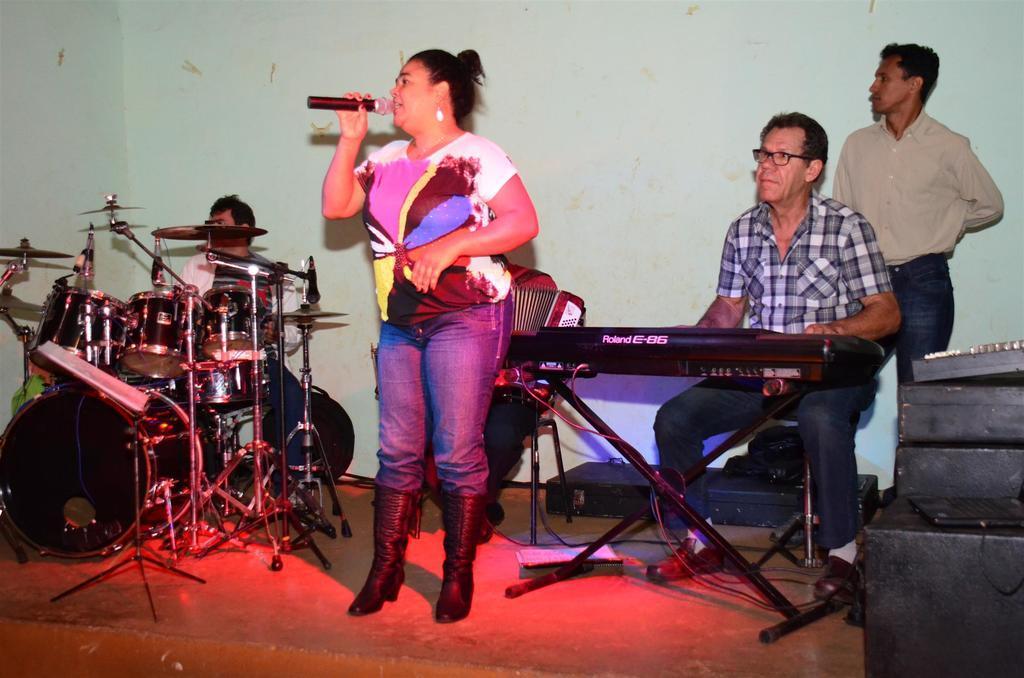Can you describe this image briefly? In this image we can see a woman is standing. She is wearing a T-shirt, jeans, shoes and holding mic in her hand. Behind her three men are playing musical instruments and one man is standing. We can see black color boxes and laptop on the right side of the image. In the background, we can see a wall. 